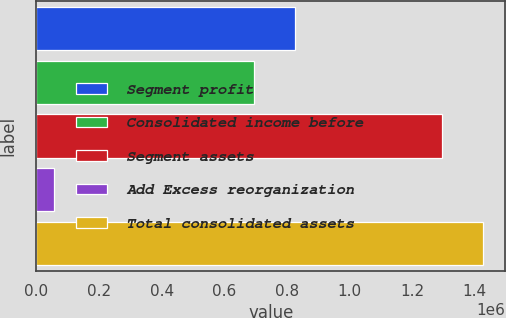Convert chart. <chart><loc_0><loc_0><loc_500><loc_500><bar_chart><fcel>Segment profit<fcel>Consolidated income before<fcel>Segment assets<fcel>Add Excess reorganization<fcel>Total consolidated assets<nl><fcel>826952<fcel>696172<fcel>1.29499e+06<fcel>55306<fcel>1.42577e+06<nl></chart> 